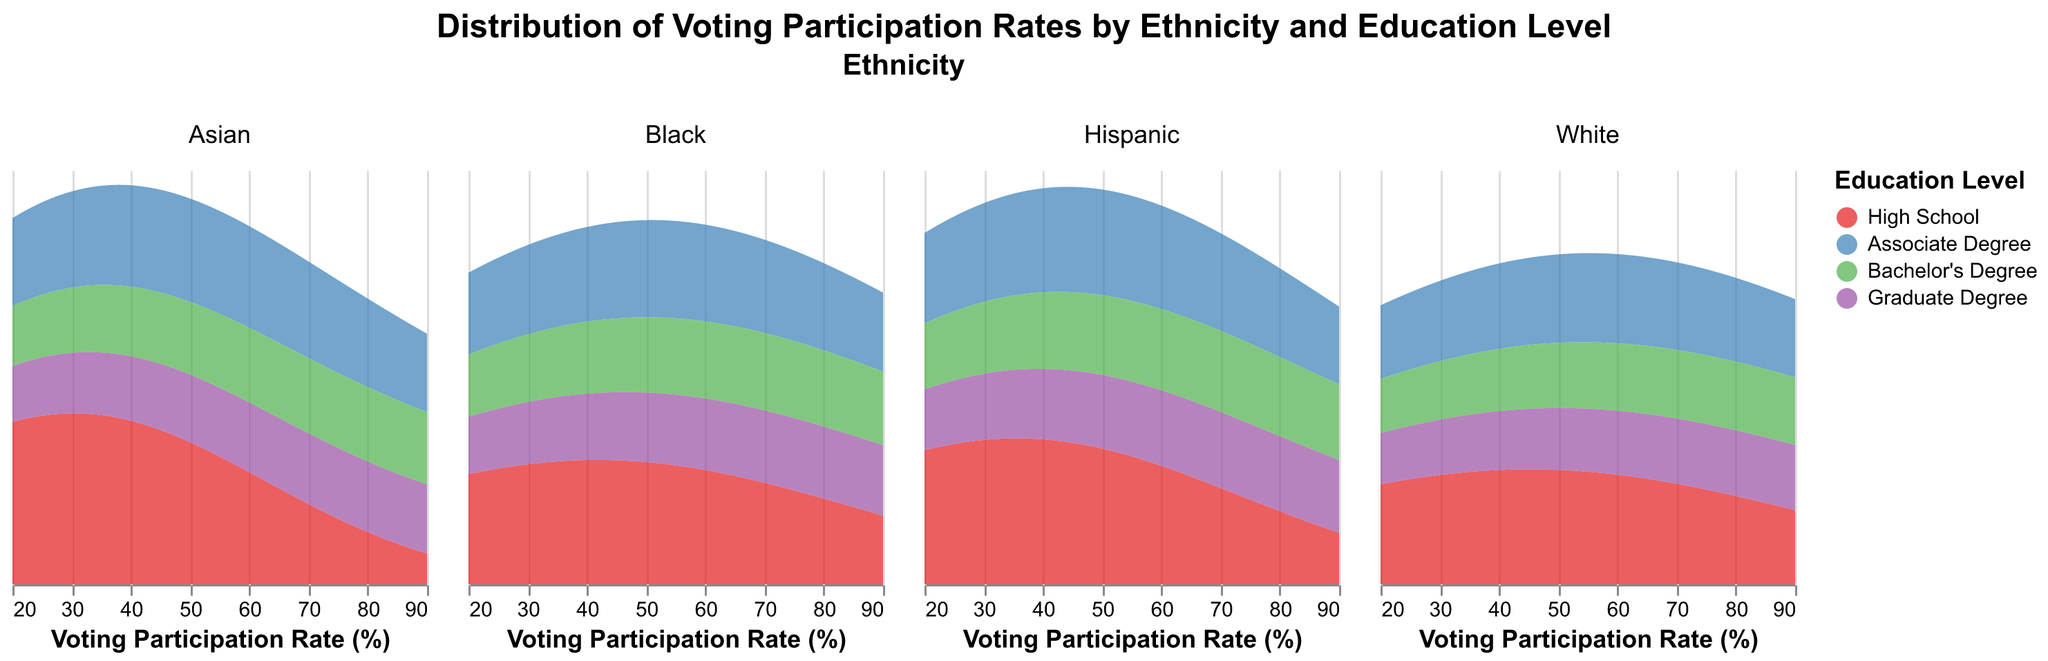What is the title of the figure? The title is displayed at the top of the figure in bold text, indicating the main subject of the visualization.
Answer: Distribution of Voting Participation Rates by Ethnicity and Education Level Which education level has the highest voting participation rate among White individuals? Look at the density plot for 'White' ethnicity and identify the peak of the area with the highest participation rate, bearing in mind the color corresponding to each education level.
Answer: Graduate Degree Compare the peak voting participation rates between individuals with a Bachelor's Degree and an Associate Degree for the Hispanic group. Which is higher? Examine the density plots for 'Hispanic' ethnicity and compare the peak values of the areas colored for Bachelor's Degree and Associate Degree.
Answer: Bachelor's Degree What is the general trend of voting participation rates as education level increases across all ethnicities? Analyze the density plots across different ethnic groups, noting changes in peak values for different education levels to identify the overall trend.
Answer: Increases Which ethnicity has the lowest peak voting participation rate for individuals with a Graduate Degree? Compare the density plots across all ethnicities specifically for the area corresponding to Graduate Degree education level and identify the lowest peak.
Answer: Hispanic For Black individuals, how does the peak voting participation rate for High School education compare to that of Associate Degree education? Examine the density plot for 'Black' ethnicity, looking at the peaks for High School and Associate Degree education levels and comparing their heights.
Answer: Associate Degree is higher How do the voting participation rates for Bachelor's Degree compare between White and Asian ethnicities? Look at the density plots for 'White' and 'Asian' ethnicities and compare the peaks of the areas colored for Bachelor's Degree education level.
Answer: White is higher Identify the education level that has the closest peak voting participation rates between the Black and Hispanic groups. Look for the density plots of 'Black' and 'Hispanic' ethnicities and identify which education level has areas with similar peak heights.
Answer: Graduate Degree What can you infer about the distribution of voting participation rates for Asian individuals with a High School education? Assess the density plot for 'Asian' ethnicity, focusing on the area corresponding to High School education level and its peak relative to the other education levels.
Answer: Relatively low Which ethnic group shows the largest increase in peak voting participation rate from High School to Bachelor's Degree? Analyze the density plots for all ethnic groups and compare the increase in peak participation rates from High School to Bachelor's Degree.
Answer: Asian 